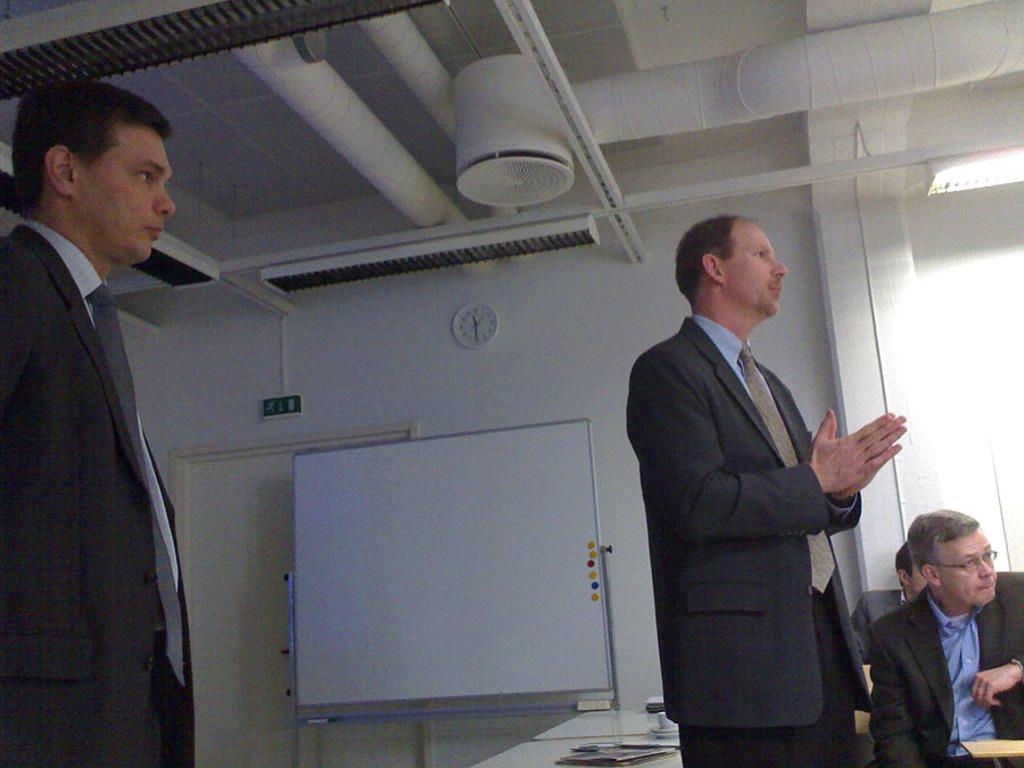In one or two sentences, can you explain what this image depicts? In the image two persons are sitting and watching. Behind them there is a table, on the table there are some papers. Behind the table there is wall and board, on the wall there is a door and sign board. At the top of the image there is ceiling. In the bottom right side of the image two persons are sitting and watching. 